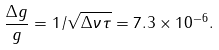<formula> <loc_0><loc_0><loc_500><loc_500>\frac { \Delta g } { g } = 1 / \sqrt { \Delta \nu \tau } = 7 . 3 \times 1 0 ^ { - 6 } .</formula> 